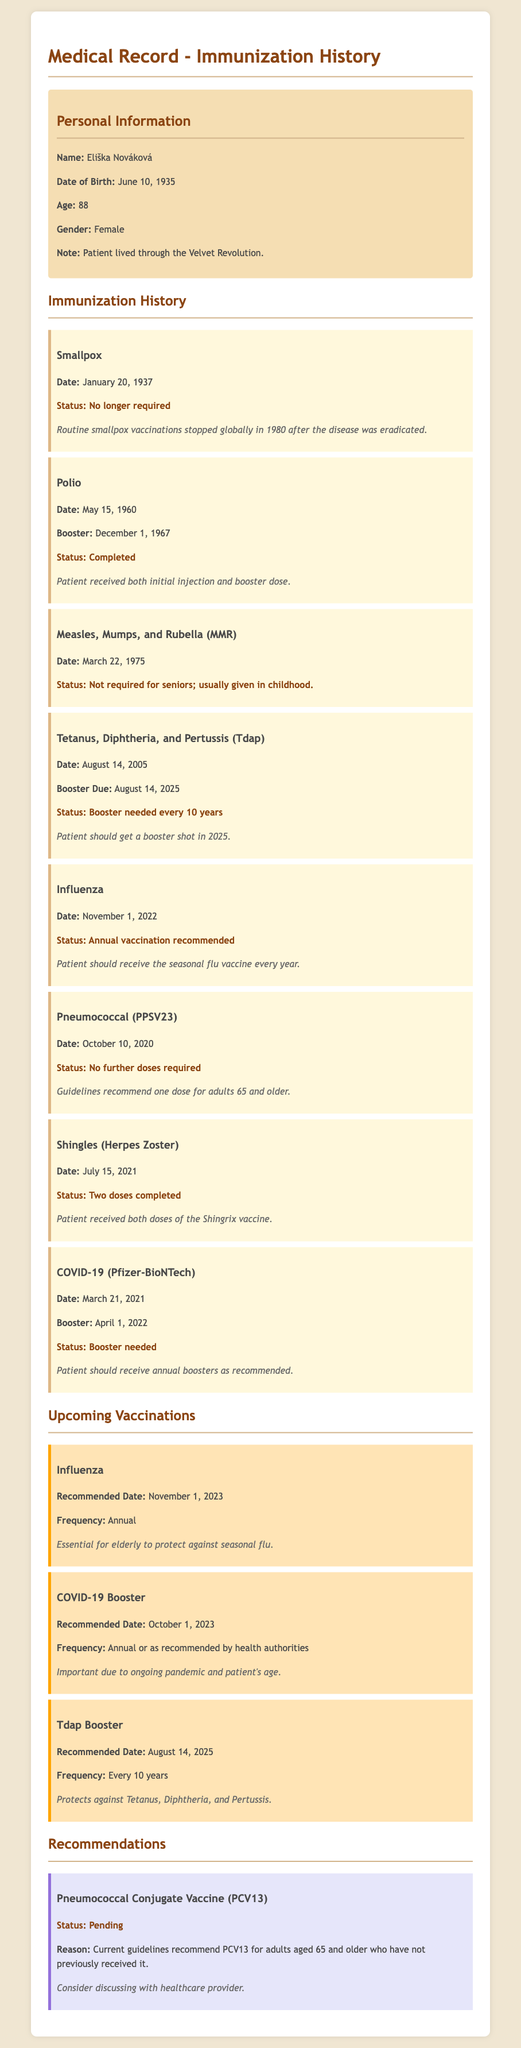What is the patient's name? The patient's name is listed under personal information in the document.
Answer: Eliška Nováková What vaccine was given on March 22, 1975? The vaccine given on this date is found in the immunization history section.
Answer: Measles, Mumps, and Rubella (MMR) When is the next Tdap booster due? The next Tdap booster due date is indicated in the immunization history section of the document.
Answer: August 14, 2025 How many doses of the Shingles vaccine has the patient completed? This information is available in the immunization history section regarding the Shingles vaccine.
Answer: Two doses completed What is the recommended date for the next COVID-19 booster? The recommended date for the next COVID-19 booster is found in the upcoming vaccinations section.
Answer: October 1, 2023 What vaccines are recommended annually for this patient? The document mentions vaccines that should be received annually, specifically in the upcoming vaccinations section.
Answer: Influenza, COVID-19 Booster 